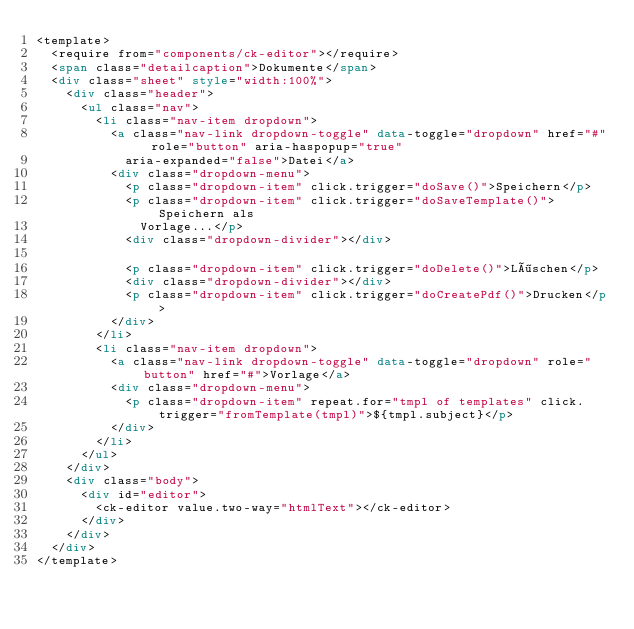<code> <loc_0><loc_0><loc_500><loc_500><_HTML_><template>
  <require from="components/ck-editor"></require>
  <span class="detailcaption">Dokumente</span>
  <div class="sheet" style="width:100%">
    <div class="header">
      <ul class="nav">
        <li class="nav-item dropdown">
          <a class="nav-link dropdown-toggle" data-toggle="dropdown" href="#" role="button" aria-haspopup="true"
            aria-expanded="false">Datei</a>
          <div class="dropdown-menu">
            <p class="dropdown-item" click.trigger="doSave()">Speichern</p>
            <p class="dropdown-item" click.trigger="doSaveTemplate()">Speichern als
              Vorlage...</p>
            <div class="dropdown-divider"></div>

            <p class="dropdown-item" click.trigger="doDelete()">Löschen</p>
            <div class="dropdown-divider"></div>
            <p class="dropdown-item" click.trigger="doCreatePdf()">Drucken</p>
          </div>
        </li>
        <li class="nav-item dropdown">
          <a class="nav-link dropdown-toggle" data-toggle="dropdown" role="button" href="#">Vorlage</a>
          <div class="dropdown-menu">
            <p class="dropdown-item" repeat.for="tmpl of templates" click.trigger="fromTemplate(tmpl)">${tmpl.subject}</p>
          </div>
        </li>
      </ul>
    </div>
    <div class="body">
      <div id="editor">
        <ck-editor value.two-way="htmlText"></ck-editor>
      </div>
    </div>
  </div>
</template>
</code> 